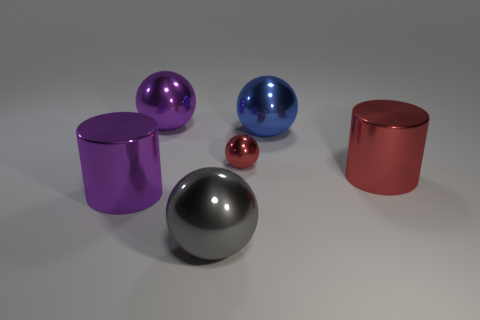Subtract all yellow cylinders. Subtract all green cubes. How many cylinders are left? 2 Add 4 big gray metallic balls. How many objects exist? 10 Subtract all cylinders. How many objects are left? 4 Add 4 cylinders. How many cylinders are left? 6 Add 2 cyan shiny cylinders. How many cyan shiny cylinders exist? 2 Subtract 0 yellow cylinders. How many objects are left? 6 Subtract all large brown metal cylinders. Subtract all big cylinders. How many objects are left? 4 